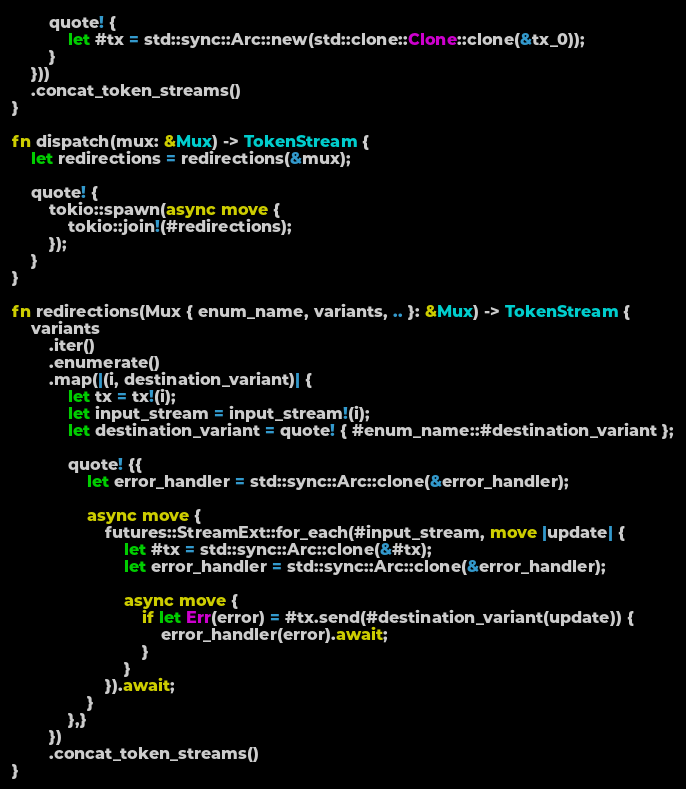Convert code to text. <code><loc_0><loc_0><loc_500><loc_500><_Rust_>
        quote! {
            let #tx = std::sync::Arc::new(std::clone::Clone::clone(&tx_0));
        }
    }))
    .concat_token_streams()
}

fn dispatch(mux: &Mux) -> TokenStream {
    let redirections = redirections(&mux);

    quote! {
        tokio::spawn(async move {
            tokio::join!(#redirections);
        });
    }
}

fn redirections(Mux { enum_name, variants, .. }: &Mux) -> TokenStream {
    variants
        .iter()
        .enumerate()
        .map(|(i, destination_variant)| {
            let tx = tx!(i);
            let input_stream = input_stream!(i);
            let destination_variant = quote! { #enum_name::#destination_variant };

            quote! {{
                let error_handler = std::sync::Arc::clone(&error_handler);

                async move {
                    futures::StreamExt::for_each(#input_stream, move |update| {
                        let #tx = std::sync::Arc::clone(&#tx);
                        let error_handler = std::sync::Arc::clone(&error_handler);

                        async move {
                            if let Err(error) = #tx.send(#destination_variant(update)) {
                                error_handler(error).await;
                            }
                        }
                    }).await;
                }
            },}
        })
        .concat_token_streams()
}
</code> 